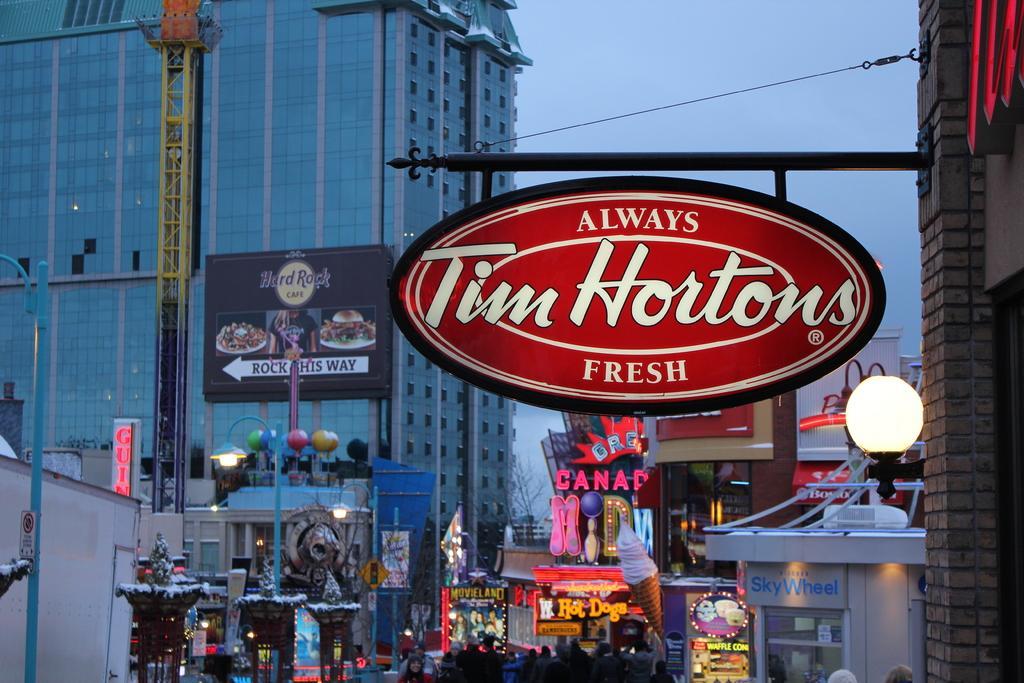Describe this image in one or two sentences. In this image in the front on the top there is a board hanging on the wall which is on the right side with some text written on it. In the center there are persons, there are boards with some text written on it and there are poles. In the background there is a building and in front of the building there is a board with some text written on it and there is stand. On the left side there is an object which is white in colour. 